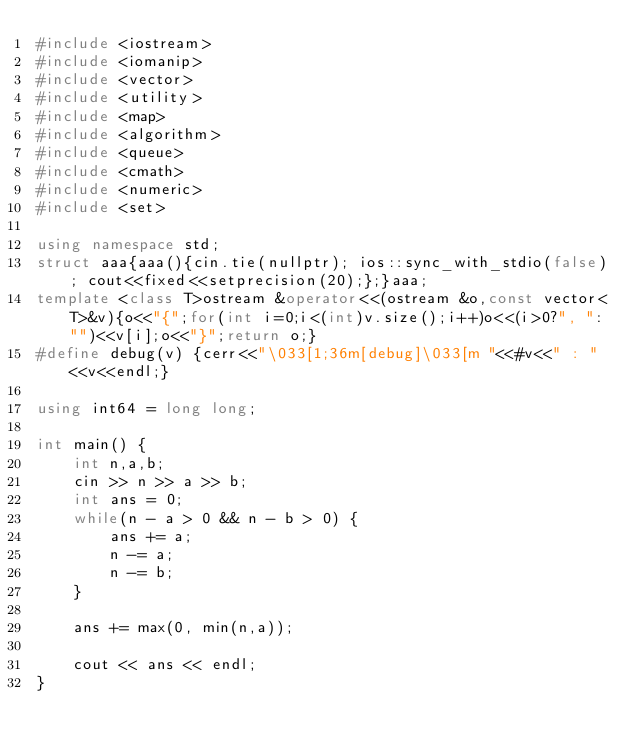<code> <loc_0><loc_0><loc_500><loc_500><_C++_>#include <iostream>
#include <iomanip>
#include <vector>
#include <utility>
#include <map>
#include <algorithm>
#include <queue>
#include <cmath>
#include <numeric>
#include <set>

using namespace std;
struct aaa{aaa(){cin.tie(nullptr); ios::sync_with_stdio(false); cout<<fixed<<setprecision(20);};}aaa;
template <class T>ostream &operator<<(ostream &o,const vector<T>&v){o<<"{";for(int i=0;i<(int)v.size();i++)o<<(i>0?", ":"")<<v[i];o<<"}";return o;}
#define debug(v) {cerr<<"\033[1;36m[debug]\033[m "<<#v<<" : "<<v<<endl;}

using int64 = long long;

int main() {
    int n,a,b;
    cin >> n >> a >> b;
    int ans = 0;
    while(n - a > 0 && n - b > 0) {
        ans += a;
        n -= a;
        n -= b;
    }

    ans += max(0, min(n,a));

    cout << ans << endl;
}</code> 